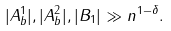Convert formula to latex. <formula><loc_0><loc_0><loc_500><loc_500>| A ^ { 1 } _ { b } | , | A ^ { 2 } _ { b } | , | B _ { 1 } | \gg n ^ { 1 - \delta } .</formula> 